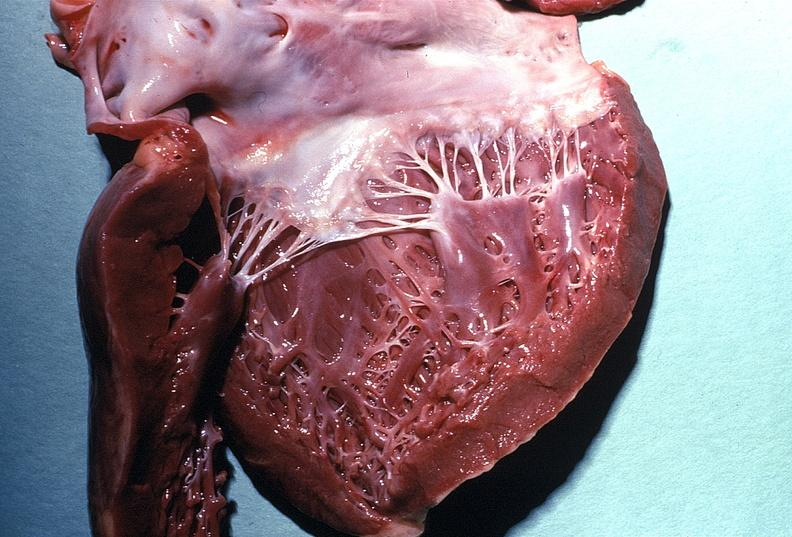what is present?
Answer the question using a single word or phrase. Cardiovascular 